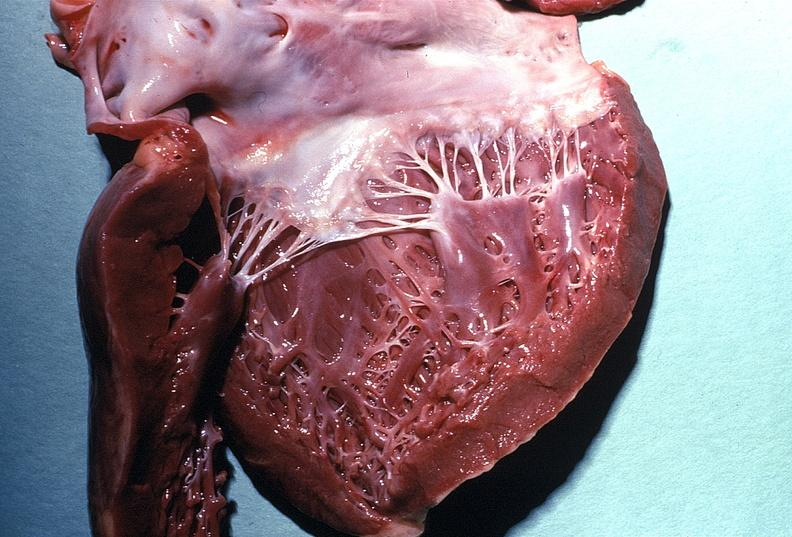what is present?
Answer the question using a single word or phrase. Cardiovascular 